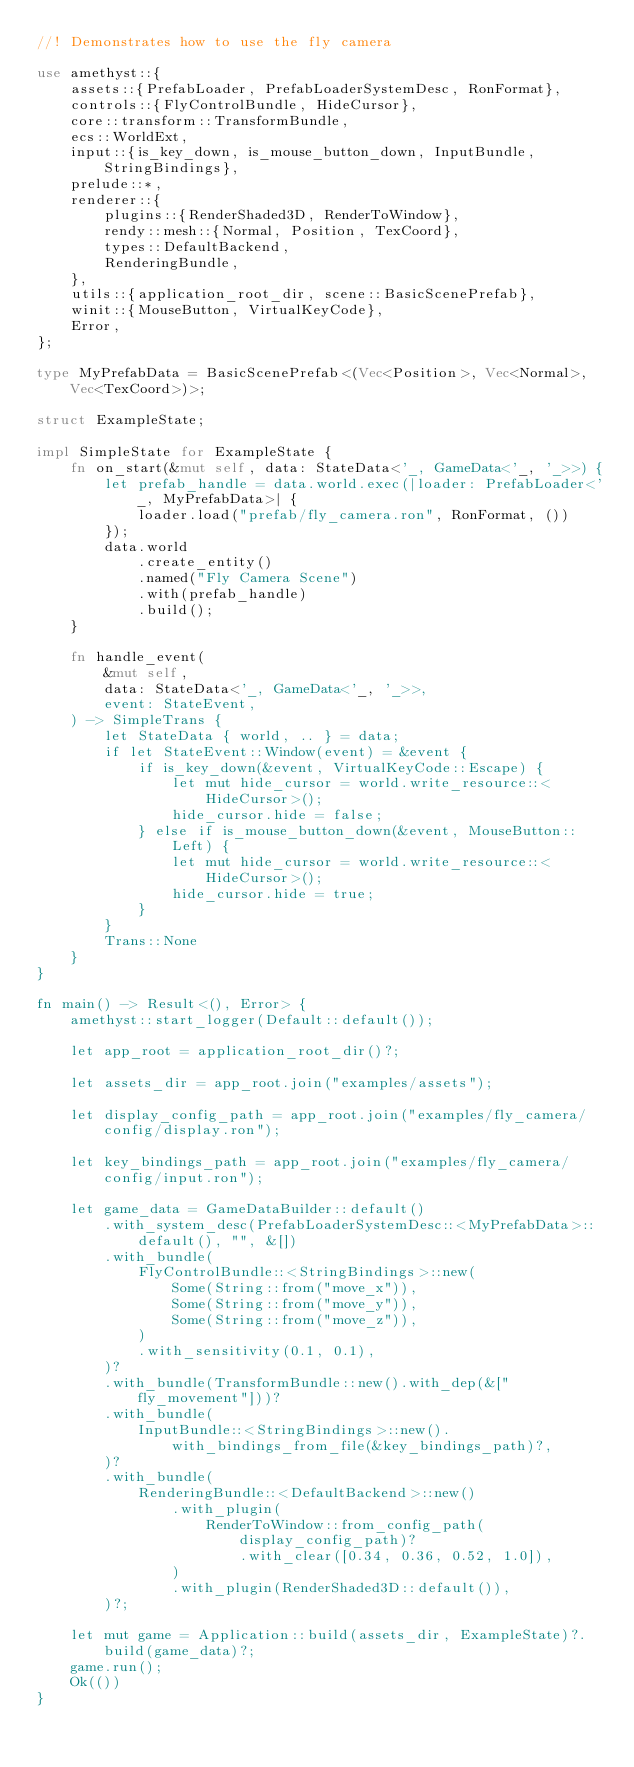Convert code to text. <code><loc_0><loc_0><loc_500><loc_500><_Rust_>//! Demonstrates how to use the fly camera

use amethyst::{
    assets::{PrefabLoader, PrefabLoaderSystemDesc, RonFormat},
    controls::{FlyControlBundle, HideCursor},
    core::transform::TransformBundle,
    ecs::WorldExt,
    input::{is_key_down, is_mouse_button_down, InputBundle, StringBindings},
    prelude::*,
    renderer::{
        plugins::{RenderShaded3D, RenderToWindow},
        rendy::mesh::{Normal, Position, TexCoord},
        types::DefaultBackend,
        RenderingBundle,
    },
    utils::{application_root_dir, scene::BasicScenePrefab},
    winit::{MouseButton, VirtualKeyCode},
    Error,
};

type MyPrefabData = BasicScenePrefab<(Vec<Position>, Vec<Normal>, Vec<TexCoord>)>;

struct ExampleState;

impl SimpleState for ExampleState {
    fn on_start(&mut self, data: StateData<'_, GameData<'_, '_>>) {
        let prefab_handle = data.world.exec(|loader: PrefabLoader<'_, MyPrefabData>| {
            loader.load("prefab/fly_camera.ron", RonFormat, ())
        });
        data.world
            .create_entity()
            .named("Fly Camera Scene")
            .with(prefab_handle)
            .build();
    }

    fn handle_event(
        &mut self,
        data: StateData<'_, GameData<'_, '_>>,
        event: StateEvent,
    ) -> SimpleTrans {
        let StateData { world, .. } = data;
        if let StateEvent::Window(event) = &event {
            if is_key_down(&event, VirtualKeyCode::Escape) {
                let mut hide_cursor = world.write_resource::<HideCursor>();
                hide_cursor.hide = false;
            } else if is_mouse_button_down(&event, MouseButton::Left) {
                let mut hide_cursor = world.write_resource::<HideCursor>();
                hide_cursor.hide = true;
            }
        }
        Trans::None
    }
}

fn main() -> Result<(), Error> {
    amethyst::start_logger(Default::default());

    let app_root = application_root_dir()?;

    let assets_dir = app_root.join("examples/assets");

    let display_config_path = app_root.join("examples/fly_camera/config/display.ron");

    let key_bindings_path = app_root.join("examples/fly_camera/config/input.ron");

    let game_data = GameDataBuilder::default()
        .with_system_desc(PrefabLoaderSystemDesc::<MyPrefabData>::default(), "", &[])
        .with_bundle(
            FlyControlBundle::<StringBindings>::new(
                Some(String::from("move_x")),
                Some(String::from("move_y")),
                Some(String::from("move_z")),
            )
            .with_sensitivity(0.1, 0.1),
        )?
        .with_bundle(TransformBundle::new().with_dep(&["fly_movement"]))?
        .with_bundle(
            InputBundle::<StringBindings>::new().with_bindings_from_file(&key_bindings_path)?,
        )?
        .with_bundle(
            RenderingBundle::<DefaultBackend>::new()
                .with_plugin(
                    RenderToWindow::from_config_path(display_config_path)?
                        .with_clear([0.34, 0.36, 0.52, 1.0]),
                )
                .with_plugin(RenderShaded3D::default()),
        )?;

    let mut game = Application::build(assets_dir, ExampleState)?.build(game_data)?;
    game.run();
    Ok(())
}
</code> 